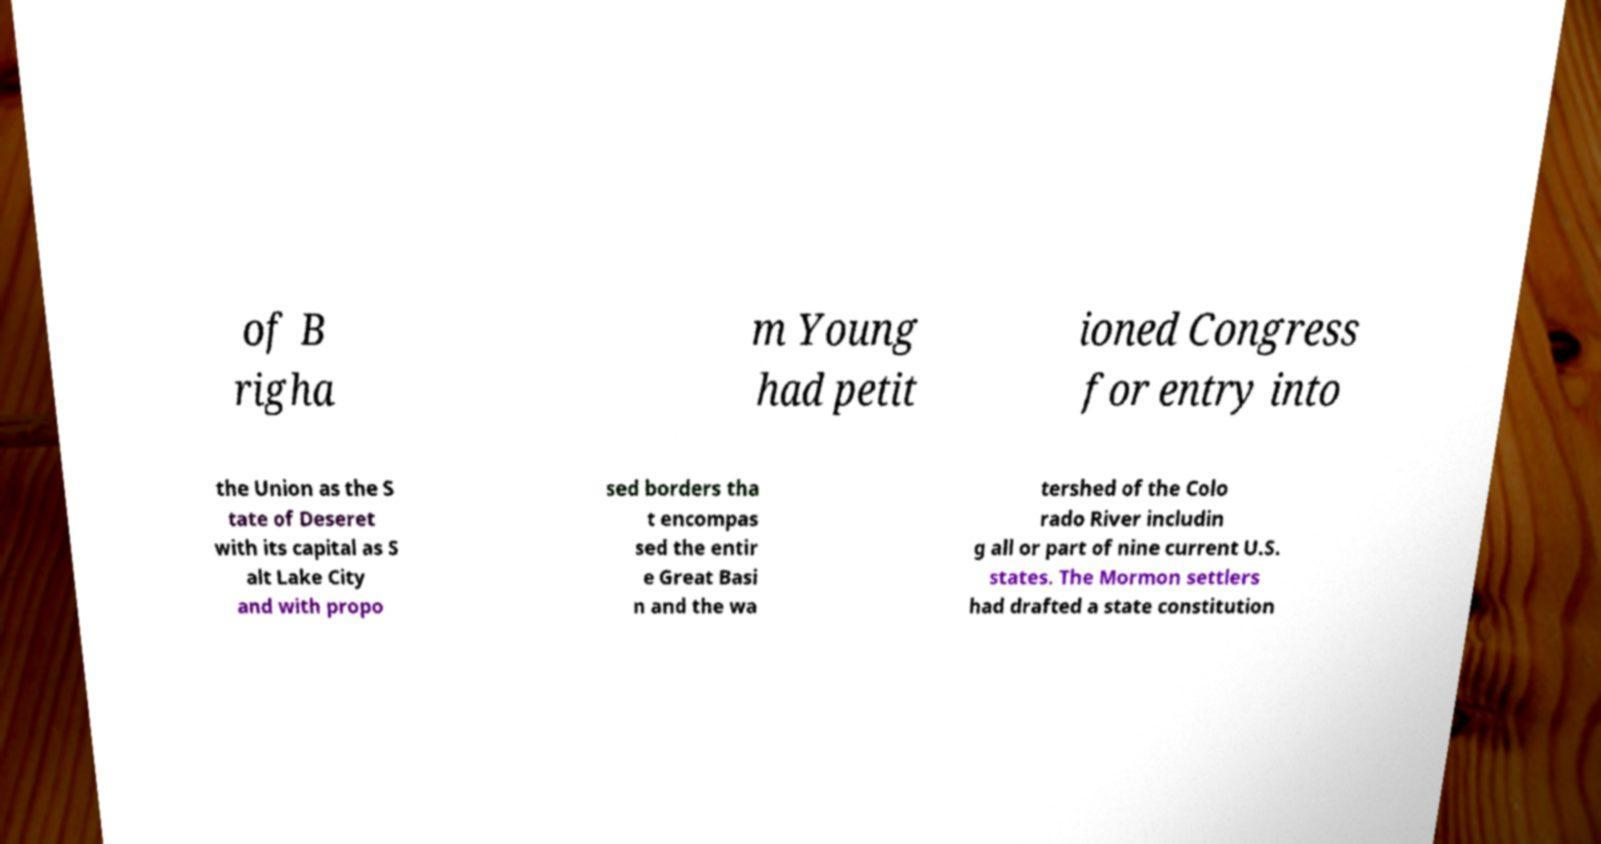For documentation purposes, I need the text within this image transcribed. Could you provide that? of B righa m Young had petit ioned Congress for entry into the Union as the S tate of Deseret with its capital as S alt Lake City and with propo sed borders tha t encompas sed the entir e Great Basi n and the wa tershed of the Colo rado River includin g all or part of nine current U.S. states. The Mormon settlers had drafted a state constitution 